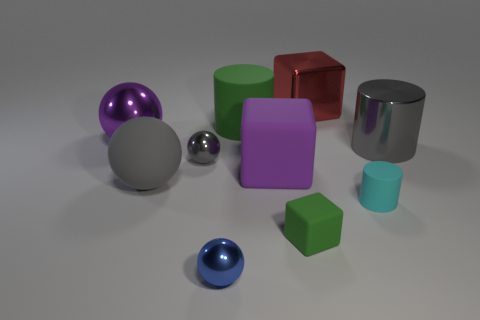Subtract 1 cubes. How many cubes are left? 2 Subtract all brown spheres. Subtract all yellow cylinders. How many spheres are left? 4 Subtract all cylinders. How many objects are left? 7 Subtract all gray rubber things. Subtract all big red metallic cubes. How many objects are left? 8 Add 1 gray things. How many gray things are left? 4 Add 3 tiny cyan cylinders. How many tiny cyan cylinders exist? 4 Subtract 0 red spheres. How many objects are left? 10 